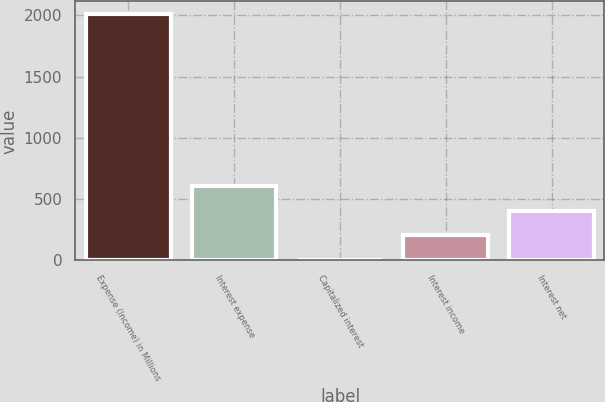Convert chart to OTSL. <chart><loc_0><loc_0><loc_500><loc_500><bar_chart><fcel>Expense (Income) in Millions<fcel>Interest expense<fcel>Capitalized interest<fcel>Interest income<fcel>Interest net<nl><fcel>2014<fcel>607.63<fcel>4.9<fcel>205.81<fcel>406.72<nl></chart> 